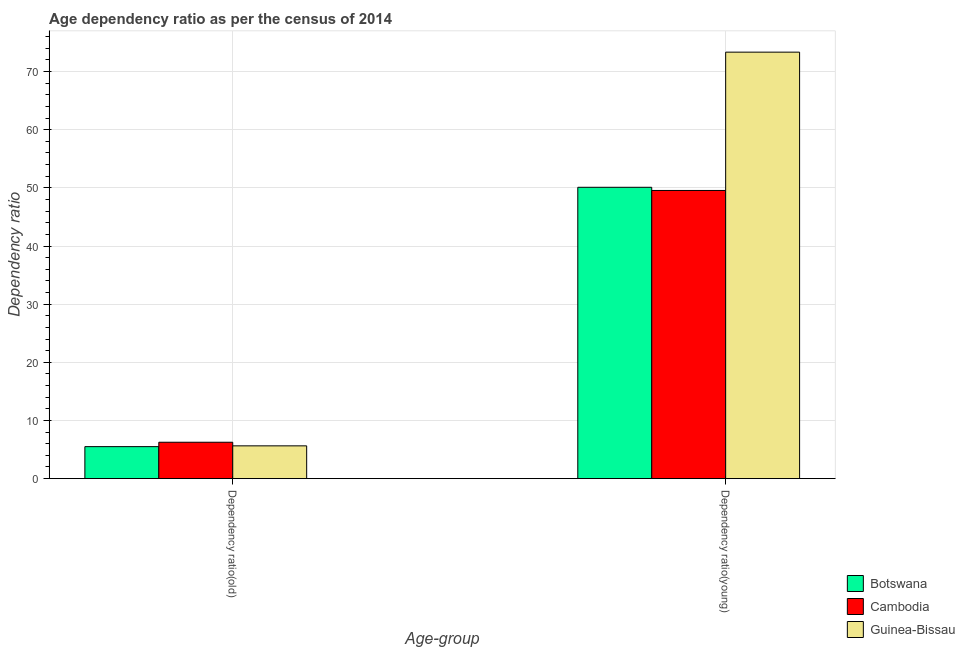Are the number of bars on each tick of the X-axis equal?
Provide a succinct answer. Yes. How many bars are there on the 1st tick from the right?
Your response must be concise. 3. What is the label of the 1st group of bars from the left?
Offer a terse response. Dependency ratio(old). What is the age dependency ratio(old) in Guinea-Bissau?
Offer a terse response. 5.63. Across all countries, what is the maximum age dependency ratio(old)?
Ensure brevity in your answer.  6.26. Across all countries, what is the minimum age dependency ratio(old)?
Your answer should be compact. 5.5. In which country was the age dependency ratio(old) maximum?
Give a very brief answer. Cambodia. In which country was the age dependency ratio(old) minimum?
Ensure brevity in your answer.  Botswana. What is the total age dependency ratio(young) in the graph?
Your answer should be compact. 173. What is the difference between the age dependency ratio(old) in Guinea-Bissau and that in Botswana?
Your answer should be compact. 0.13. What is the difference between the age dependency ratio(old) in Botswana and the age dependency ratio(young) in Guinea-Bissau?
Make the answer very short. -67.84. What is the average age dependency ratio(young) per country?
Your answer should be compact. 57.67. What is the difference between the age dependency ratio(old) and age dependency ratio(young) in Cambodia?
Offer a terse response. -43.3. In how many countries, is the age dependency ratio(young) greater than 12 ?
Provide a succinct answer. 3. What is the ratio of the age dependency ratio(young) in Cambodia to that in Botswana?
Your answer should be very brief. 0.99. In how many countries, is the age dependency ratio(young) greater than the average age dependency ratio(young) taken over all countries?
Your answer should be very brief. 1. What does the 3rd bar from the left in Dependency ratio(young) represents?
Your response must be concise. Guinea-Bissau. What does the 1st bar from the right in Dependency ratio(old) represents?
Provide a succinct answer. Guinea-Bissau. How many bars are there?
Offer a terse response. 6. How many countries are there in the graph?
Give a very brief answer. 3. Are the values on the major ticks of Y-axis written in scientific E-notation?
Make the answer very short. No. Does the graph contain any zero values?
Your response must be concise. No. Where does the legend appear in the graph?
Keep it short and to the point. Bottom right. What is the title of the graph?
Your response must be concise. Age dependency ratio as per the census of 2014. Does "Virgin Islands" appear as one of the legend labels in the graph?
Give a very brief answer. No. What is the label or title of the X-axis?
Your answer should be very brief. Age-group. What is the label or title of the Y-axis?
Offer a terse response. Dependency ratio. What is the Dependency ratio of Botswana in Dependency ratio(old)?
Keep it short and to the point. 5.5. What is the Dependency ratio in Cambodia in Dependency ratio(old)?
Give a very brief answer. 6.26. What is the Dependency ratio in Guinea-Bissau in Dependency ratio(old)?
Provide a short and direct response. 5.63. What is the Dependency ratio of Botswana in Dependency ratio(young)?
Provide a short and direct response. 50.1. What is the Dependency ratio of Cambodia in Dependency ratio(young)?
Keep it short and to the point. 49.55. What is the Dependency ratio of Guinea-Bissau in Dependency ratio(young)?
Provide a succinct answer. 73.34. Across all Age-group, what is the maximum Dependency ratio in Botswana?
Make the answer very short. 50.1. Across all Age-group, what is the maximum Dependency ratio of Cambodia?
Make the answer very short. 49.55. Across all Age-group, what is the maximum Dependency ratio of Guinea-Bissau?
Offer a terse response. 73.34. Across all Age-group, what is the minimum Dependency ratio of Botswana?
Provide a short and direct response. 5.5. Across all Age-group, what is the minimum Dependency ratio of Cambodia?
Your answer should be very brief. 6.26. Across all Age-group, what is the minimum Dependency ratio in Guinea-Bissau?
Offer a very short reply. 5.63. What is the total Dependency ratio in Botswana in the graph?
Make the answer very short. 55.6. What is the total Dependency ratio in Cambodia in the graph?
Provide a short and direct response. 55.81. What is the total Dependency ratio of Guinea-Bissau in the graph?
Make the answer very short. 78.97. What is the difference between the Dependency ratio of Botswana in Dependency ratio(old) and that in Dependency ratio(young)?
Offer a very short reply. -44.6. What is the difference between the Dependency ratio in Cambodia in Dependency ratio(old) and that in Dependency ratio(young)?
Provide a succinct answer. -43.3. What is the difference between the Dependency ratio of Guinea-Bissau in Dependency ratio(old) and that in Dependency ratio(young)?
Offer a very short reply. -67.71. What is the difference between the Dependency ratio in Botswana in Dependency ratio(old) and the Dependency ratio in Cambodia in Dependency ratio(young)?
Ensure brevity in your answer.  -44.05. What is the difference between the Dependency ratio in Botswana in Dependency ratio(old) and the Dependency ratio in Guinea-Bissau in Dependency ratio(young)?
Provide a short and direct response. -67.84. What is the difference between the Dependency ratio of Cambodia in Dependency ratio(old) and the Dependency ratio of Guinea-Bissau in Dependency ratio(young)?
Keep it short and to the point. -67.09. What is the average Dependency ratio of Botswana per Age-group?
Your answer should be very brief. 27.8. What is the average Dependency ratio in Cambodia per Age-group?
Make the answer very short. 27.9. What is the average Dependency ratio in Guinea-Bissau per Age-group?
Your answer should be compact. 39.49. What is the difference between the Dependency ratio in Botswana and Dependency ratio in Cambodia in Dependency ratio(old)?
Your answer should be very brief. -0.76. What is the difference between the Dependency ratio in Botswana and Dependency ratio in Guinea-Bissau in Dependency ratio(old)?
Provide a short and direct response. -0.13. What is the difference between the Dependency ratio in Cambodia and Dependency ratio in Guinea-Bissau in Dependency ratio(old)?
Provide a succinct answer. 0.62. What is the difference between the Dependency ratio in Botswana and Dependency ratio in Cambodia in Dependency ratio(young)?
Keep it short and to the point. 0.55. What is the difference between the Dependency ratio of Botswana and Dependency ratio of Guinea-Bissau in Dependency ratio(young)?
Your answer should be very brief. -23.24. What is the difference between the Dependency ratio in Cambodia and Dependency ratio in Guinea-Bissau in Dependency ratio(young)?
Provide a short and direct response. -23.79. What is the ratio of the Dependency ratio of Botswana in Dependency ratio(old) to that in Dependency ratio(young)?
Keep it short and to the point. 0.11. What is the ratio of the Dependency ratio of Cambodia in Dependency ratio(old) to that in Dependency ratio(young)?
Your response must be concise. 0.13. What is the ratio of the Dependency ratio of Guinea-Bissau in Dependency ratio(old) to that in Dependency ratio(young)?
Offer a terse response. 0.08. What is the difference between the highest and the second highest Dependency ratio of Botswana?
Your answer should be very brief. 44.6. What is the difference between the highest and the second highest Dependency ratio of Cambodia?
Keep it short and to the point. 43.3. What is the difference between the highest and the second highest Dependency ratio of Guinea-Bissau?
Provide a succinct answer. 67.71. What is the difference between the highest and the lowest Dependency ratio of Botswana?
Give a very brief answer. 44.6. What is the difference between the highest and the lowest Dependency ratio in Cambodia?
Your answer should be very brief. 43.3. What is the difference between the highest and the lowest Dependency ratio in Guinea-Bissau?
Provide a short and direct response. 67.71. 